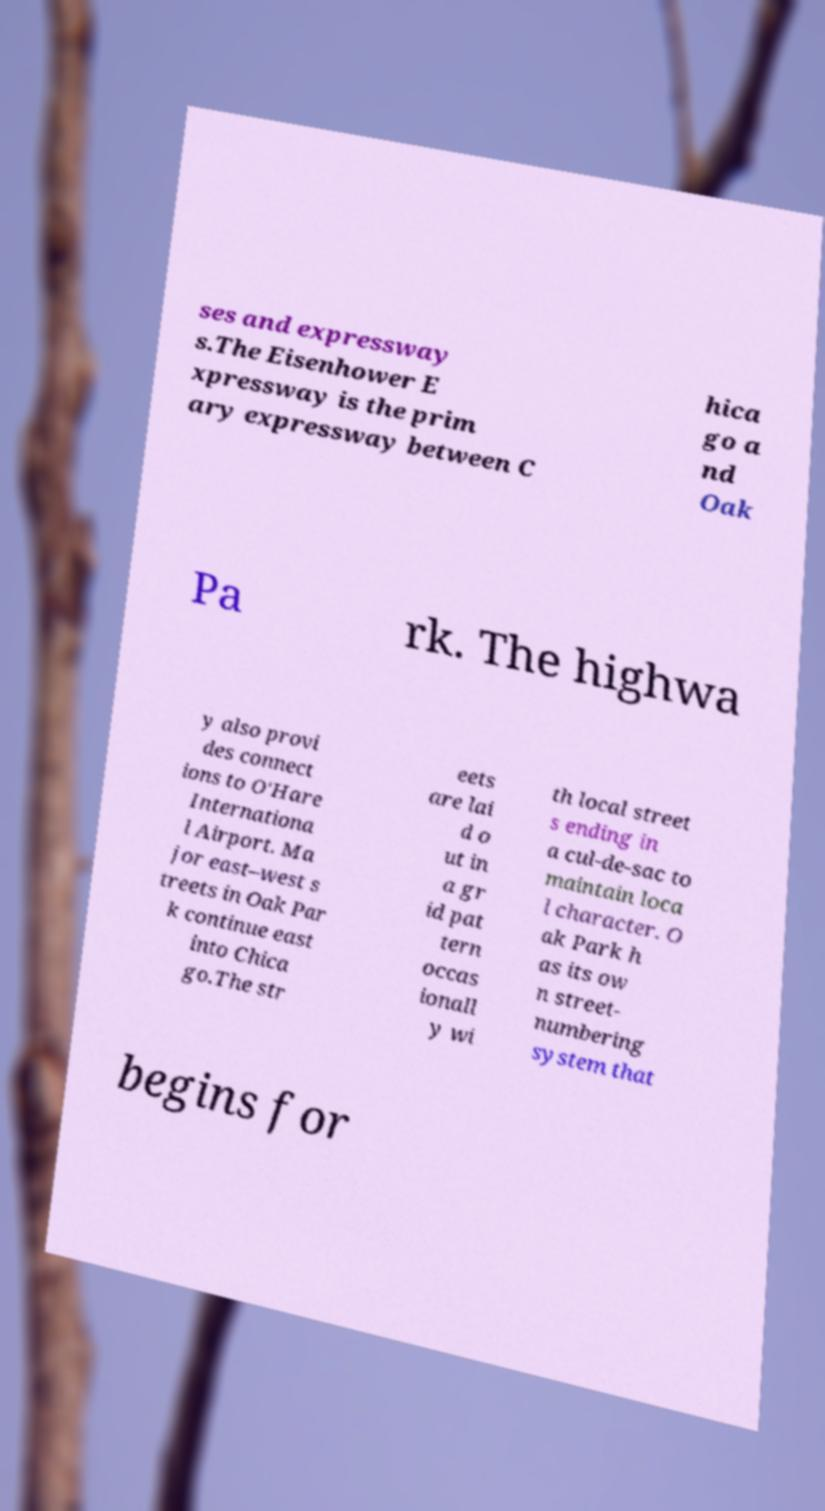Can you read and provide the text displayed in the image?This photo seems to have some interesting text. Can you extract and type it out for me? ses and expressway s.The Eisenhower E xpressway is the prim ary expressway between C hica go a nd Oak Pa rk. The highwa y also provi des connect ions to O'Hare Internationa l Airport. Ma jor east–west s treets in Oak Par k continue east into Chica go.The str eets are lai d o ut in a gr id pat tern occas ionall y wi th local street s ending in a cul-de-sac to maintain loca l character. O ak Park h as its ow n street- numbering system that begins for 